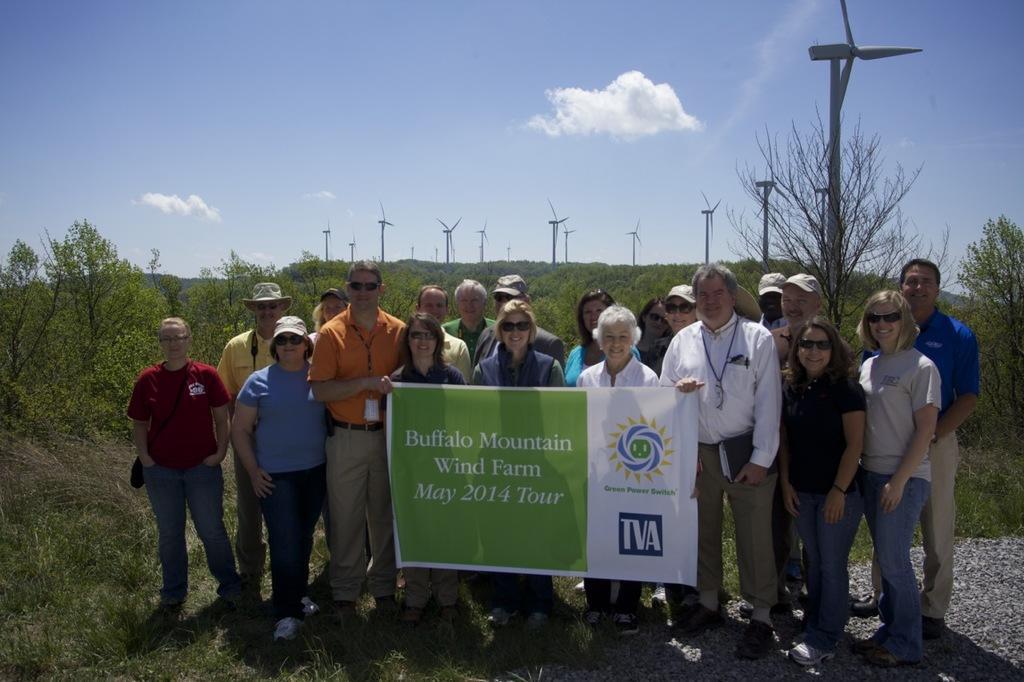Can you describe this image briefly? There is a group of persons standing at the bottom of this image, and there are some persons holding a poster. There are some trees and turbines in the background. There is a cloudy sky at the top of this image. 